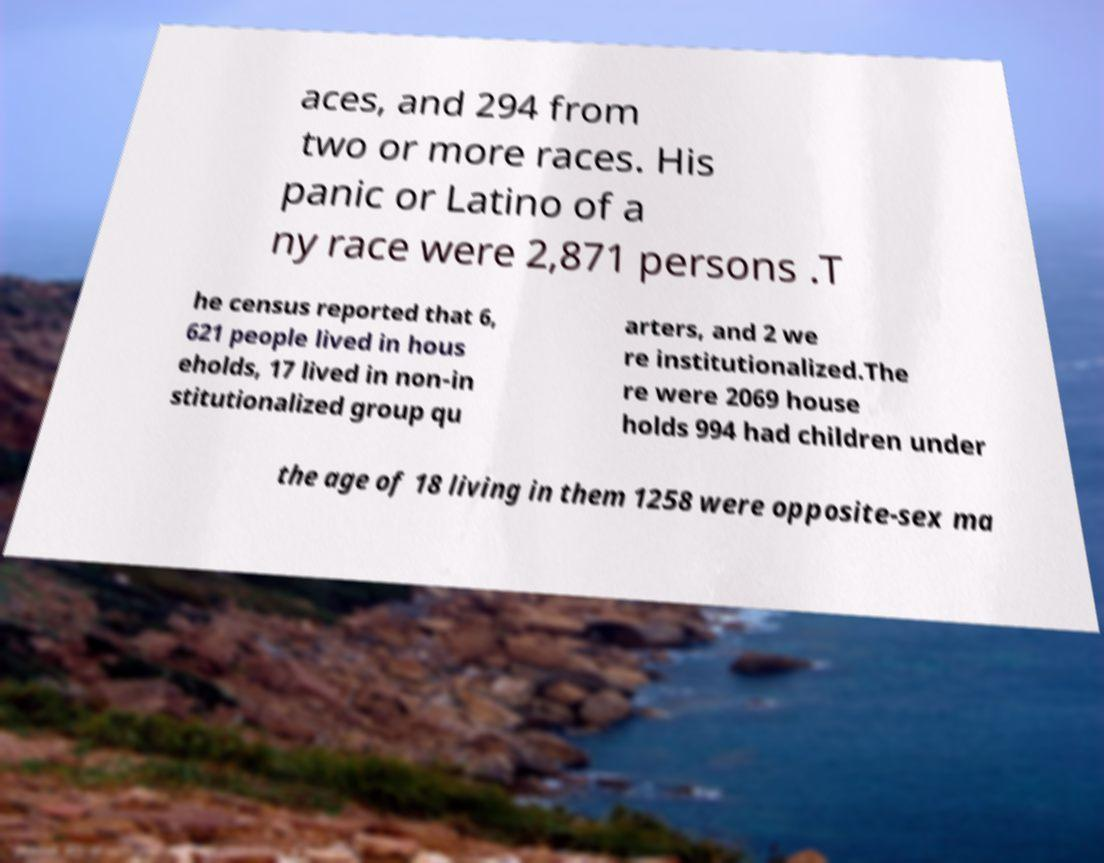Could you extract and type out the text from this image? aces, and 294 from two or more races. His panic or Latino of a ny race were 2,871 persons .T he census reported that 6, 621 people lived in hous eholds, 17 lived in non-in stitutionalized group qu arters, and 2 we re institutionalized.The re were 2069 house holds 994 had children under the age of 18 living in them 1258 were opposite-sex ma 